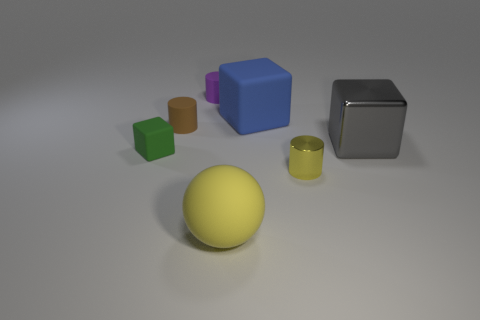What is the shape of the yellow object that is in front of the small cylinder in front of the gray thing?
Offer a terse response. Sphere. Are any tiny gray rubber balls visible?
Your answer should be compact. No. How many spheres are to the left of the small cylinder that is on the right side of the matte object in front of the tiny metallic thing?
Offer a very short reply. 1. Do the tiny shiny thing and the brown rubber object in front of the tiny purple rubber thing have the same shape?
Offer a terse response. Yes. Are there more metallic things than tiny green rubber things?
Your answer should be very brief. Yes. Are there any other things that are the same size as the gray thing?
Provide a short and direct response. Yes. There is a yellow thing behind the big yellow rubber object; does it have the same shape as the purple thing?
Give a very brief answer. Yes. Are there more large things that are left of the blue cube than small red shiny cubes?
Ensure brevity in your answer.  Yes. What color is the matte thing in front of the small object on the left side of the brown object?
Keep it short and to the point. Yellow. What number of small green shiny spheres are there?
Provide a short and direct response. 0. 